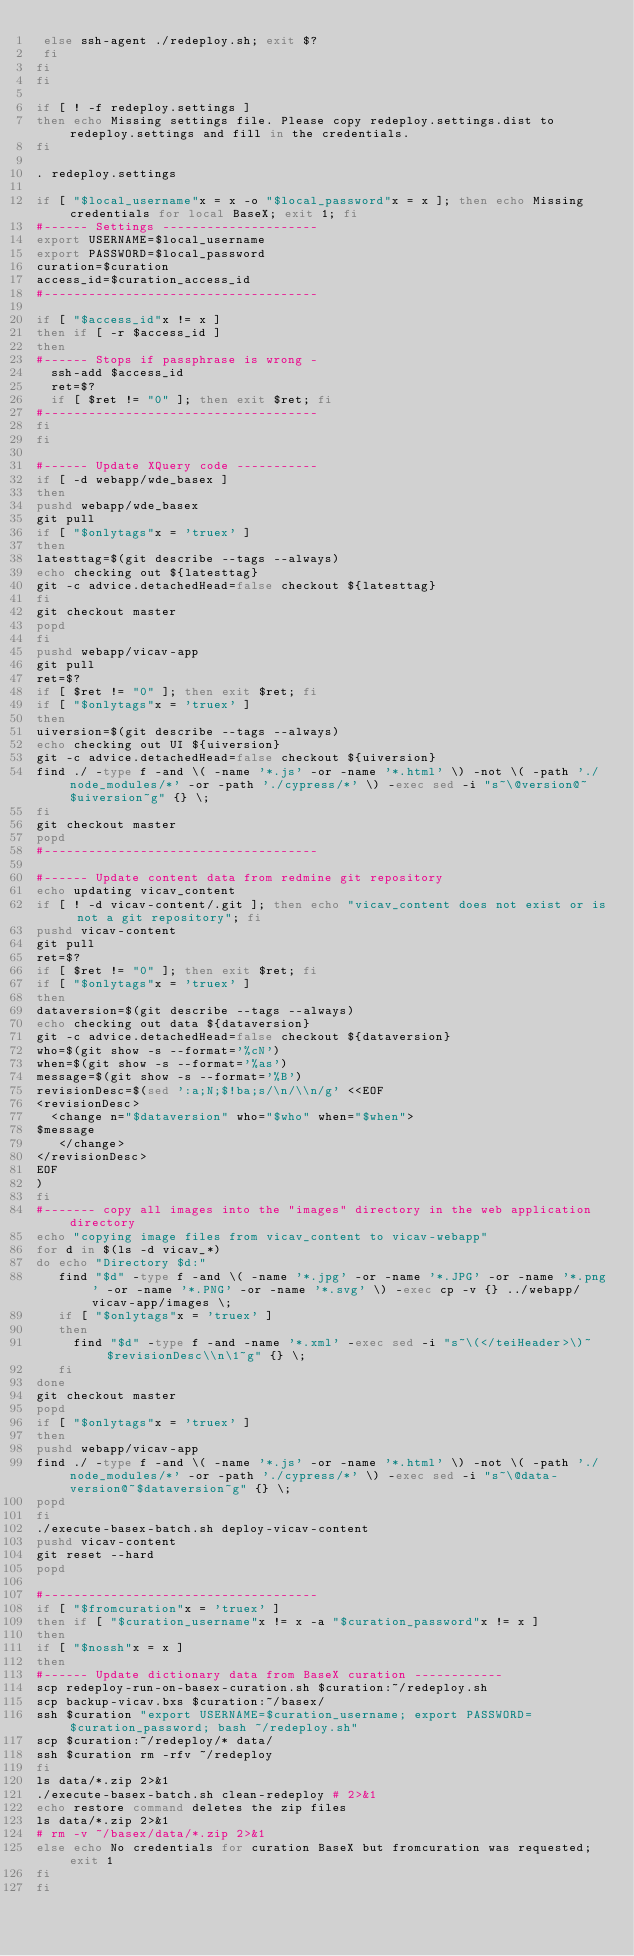Convert code to text. <code><loc_0><loc_0><loc_500><loc_500><_Bash_> else ssh-agent ./redeploy.sh; exit $?
 fi
fi
fi

if [ ! -f redeploy.settings ]
then echo Missing settings file. Please copy redeploy.settings.dist to redeploy.settings and fill in the credentials.
fi

. redeploy.settings

if [ "$local_username"x = x -o "$local_password"x = x ]; then echo Missing credentials for local BaseX; exit 1; fi
#------ Settings ---------------------
export USERNAME=$local_username
export PASSWORD=$local_password
curation=$curation
access_id=$curation_access_id
#-------------------------------------

if [ "$access_id"x != x ]
then if [ -r $access_id ]
then
#------ Stops if passphrase is wrong -
  ssh-add $access_id
  ret=$?
  if [ $ret != "0" ]; then exit $ret; fi
#-------------------------------------
fi
fi

#------ Update XQuery code -----------
if [ -d webapp/wde_basex ]
then
pushd webapp/wde_basex
git pull
if [ "$onlytags"x = 'truex' ]
then
latesttag=$(git describe --tags --always)
echo checking out ${latesttag}
git -c advice.detachedHead=false checkout ${latesttag}
fi
git checkout master
popd
fi
pushd webapp/vicav-app
git pull
ret=$?
if [ $ret != "0" ]; then exit $ret; fi
if [ "$onlytags"x = 'truex' ]
then
uiversion=$(git describe --tags --always)
echo checking out UI ${uiversion}
git -c advice.detachedHead=false checkout ${uiversion}
find ./ -type f -and \( -name '*.js' -or -name '*.html' \) -not \( -path './node_modules/*' -or -path './cypress/*' \) -exec sed -i "s~\@version@~$uiversion~g" {} \;
fi
git checkout master
popd
#-------------------------------------

#------ Update content data from redmine git repository 
echo updating vicav_content 
if [ ! -d vicav-content/.git ]; then echo "vicav_content does not exist or is not a git repository"; fi
pushd vicav-content
git pull
ret=$?
if [ $ret != "0" ]; then exit $ret; fi
if [ "$onlytags"x = 'truex' ]
then
dataversion=$(git describe --tags --always)
echo checking out data ${dataversion}
git -c advice.detachedHead=false checkout ${dataversion}
who=$(git show -s --format='%cN')
when=$(git show -s --format='%as')
message=$(git show -s --format='%B')
revisionDesc=$(sed ':a;N;$!ba;s/\n/\\n/g' <<EOF
<revisionDesc>
  <change n="$dataversion" who="$who" when="$when">
$message
   </change>
</revisionDesc>
EOF
)
fi
#------- copy all images into the "images" directory in the web application directory
echo "copying image files from vicav_content to vicav-webapp"
for d in $(ls -d vicav_*)
do echo "Directory $d:"
   find "$d" -type f -and \( -name '*.jpg' -or -name '*.JPG' -or -name '*.png' -or -name '*.PNG' -or -name '*.svg' \) -exec cp -v {} ../webapp/vicav-app/images \;
   if [ "$onlytags"x = 'truex' ]
   then
     find "$d" -type f -and -name '*.xml' -exec sed -i "s~\(</teiHeader>\)~$revisionDesc\\n\1~g" {} \;
   fi
done
git checkout master
popd
if [ "$onlytags"x = 'truex' ]
then
pushd webapp/vicav-app
find ./ -type f -and \( -name '*.js' -or -name '*.html' \) -not \( -path './node_modules/*' -or -path './cypress/*' \) -exec sed -i "s~\@data-version@~$dataversion~g" {} \;
popd
fi
./execute-basex-batch.sh deploy-vicav-content
pushd vicav-content
git reset --hard
popd

#-------------------------------------
if [ "$fromcuration"x = 'truex' ]
then if [ "$curation_username"x != x -a "$curation_password"x != x ]
then
if [ "$nossh"x = x ]
then
#------ Update dictionary data from BaseX curation ------------
scp redeploy-run-on-basex-curation.sh $curation:~/redeploy.sh
scp backup-vicav.bxs $curation:~/basex/
ssh $curation "export USERNAME=$curation_username; export PASSWORD=$curation_password; bash ~/redeploy.sh"
scp $curation:~/redeploy/* data/
ssh $curation rm -rfv ~/redeploy
fi
ls data/*.zip 2>&1
./execute-basex-batch.sh clean-redeploy # 2>&1
echo restore command deletes the zip files
ls data/*.zip 2>&1
# rm -v ~/basex/data/*.zip 2>&1
else echo No credentials for curation BaseX but fromcuration was requested; exit 1
fi
fi
</code> 